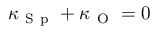<formula> <loc_0><loc_0><loc_500><loc_500>\kappa _ { S p } + \kappa _ { O } = 0</formula> 